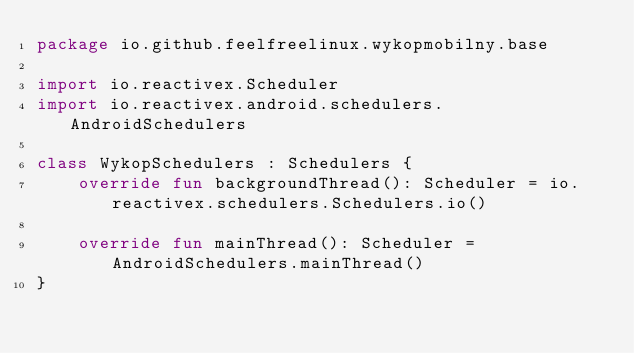<code> <loc_0><loc_0><loc_500><loc_500><_Kotlin_>package io.github.feelfreelinux.wykopmobilny.base

import io.reactivex.Scheduler
import io.reactivex.android.schedulers.AndroidSchedulers

class WykopSchedulers : Schedulers {
    override fun backgroundThread(): Scheduler = io.reactivex.schedulers.Schedulers.io()

    override fun mainThread(): Scheduler = AndroidSchedulers.mainThread()
}</code> 